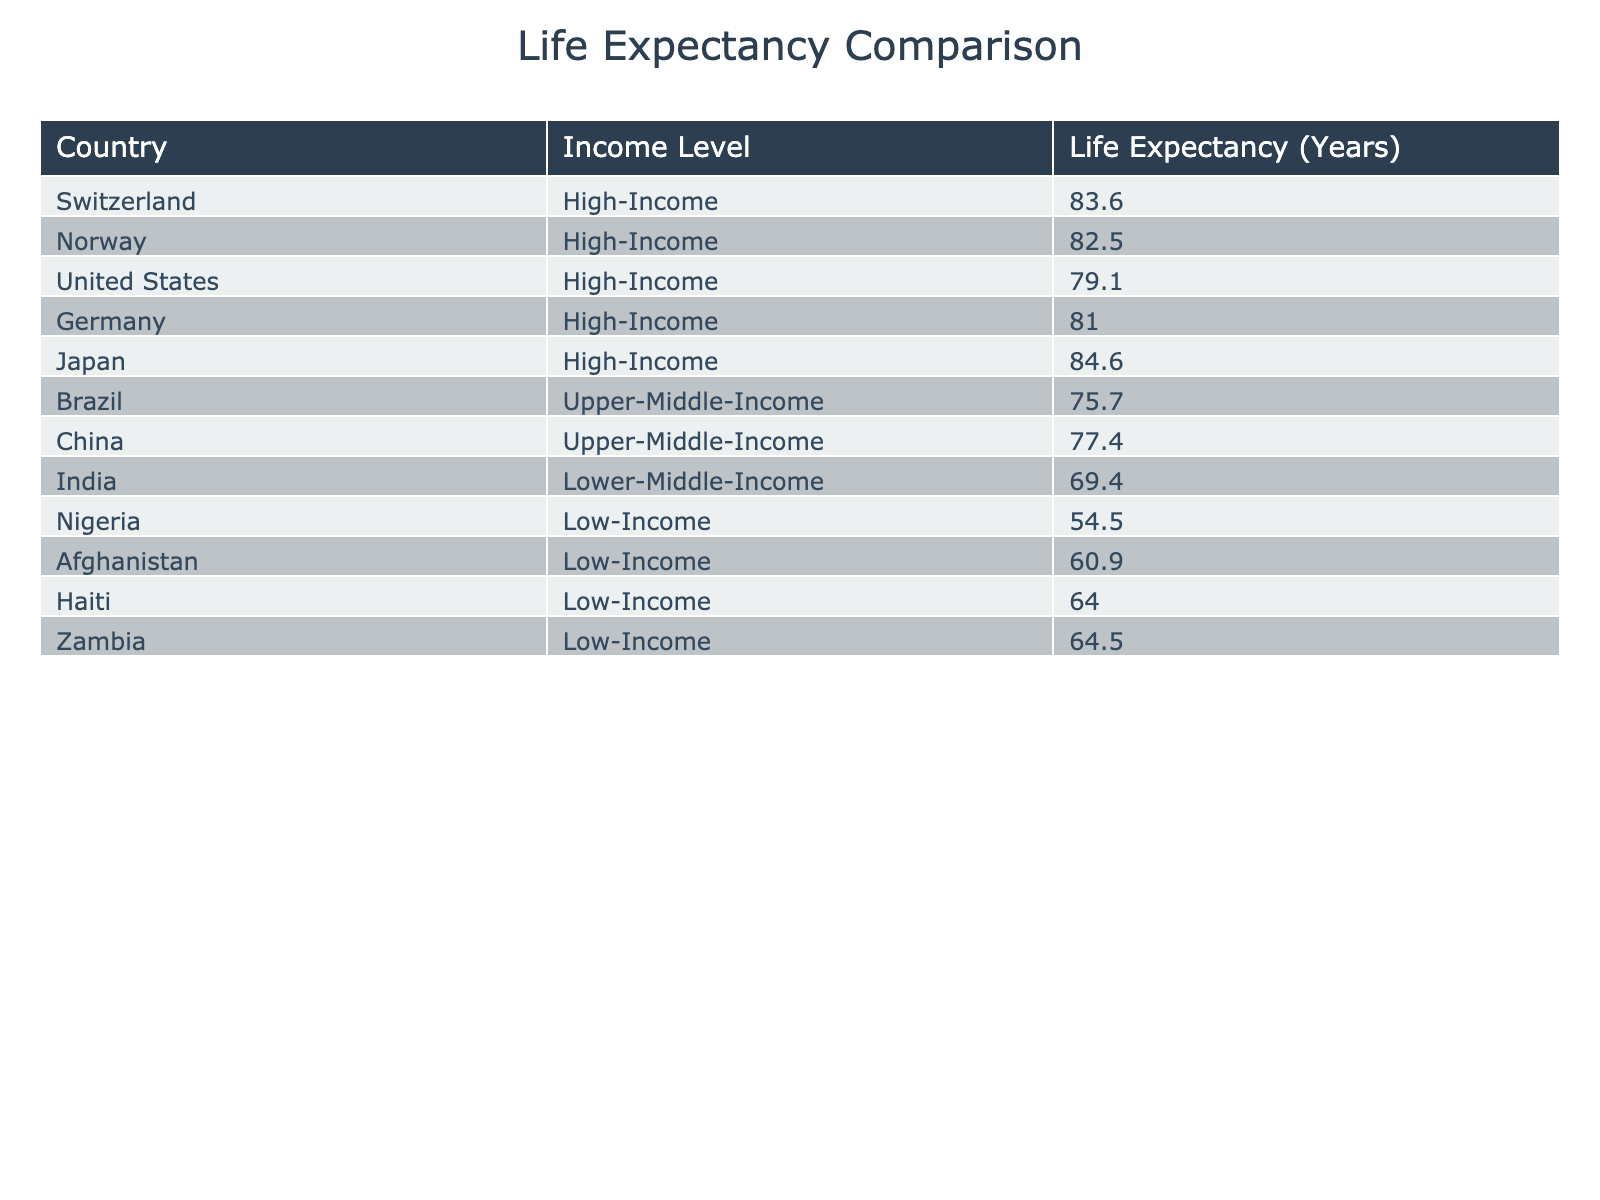What is the life expectancy in Switzerland? Looking at the table, Switzerland is listed under the high-income category, and its life expectancy is provided as 83.6 years.
Answer: 83.6 years Which country has the lowest life expectancy? The table lists multiple countries, and by comparing their life expectancies, Nigeria has the lowest at 54.5 years.
Answer: Nigeria (54.5 years) Is the life expectancy in high-income countries generally higher than in low-income countries? From the table, high-income countries have consistently higher life expectancies compared to low-income countries, such as Nigeria (54.5 years) and Afghanistan (60.9 years).
Answer: Yes What is the difference in life expectancy between the United States and Afghanistan? The life expectancy in the United States is 79.1 years, while in Afghanistan it is 60.9 years. The difference is calculated as 79.1 - 60.9 = 18.2 years.
Answer: 18.2 years What is the average life expectancy of the low-income countries listed? The low-income countries listed are Nigeria (54.5), Afghanistan (60.9), Haiti (64.0), and Zambia (64.5). To find the average, we sum these values: 54.5 + 60.9 + 64.0 + 64.5 = 244. The average is then calculated by dividing by the number of countries: 244 / 4 = 61.0 years.
Answer: 61.0 years Does any country in the upper-middle-income group have a life expectancy greater than Japan's? Japan's life expectancy is the highest in the table at 84.6 years. In the upper-middle-income group, the highest life expectancy is China at 77.4 years, which is less than Japan's.
Answer: No If we compare the average life expectancies between high-income and low-income countries, how many years higher is high-income? The average life expectancy for high-income countries from the table includes Switzerland (83.6), Norway (82.5), the United States (79.1), Germany (81.0), and Japan (84.6). The average is calculated as (83.6 + 82.5 + 79.1 + 81.0 + 84.6) / 5 = 82.816 years. For low-income countries (Nigeria, Afghanistan, Haiti, and Zambia), the average is 61.0 years, thus the difference is 82.816 - 61.0 = 21.816 years.
Answer: 21.8 years Which country has a life expectancy closest to the average of low-income countries? The average life expectancy for low-income countries is 61.0 years. Among the listed countries under low income, Haiti has a life expectancy of 64.0 years, which is closest to the average.
Answer: Haiti (64.0 years) 